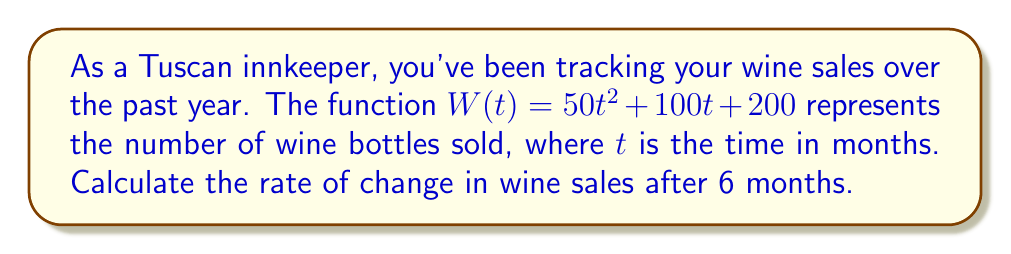Could you help me with this problem? To find the rate of change in wine sales after 6 months, we need to calculate the derivative of the given function $W(t)$ and then evaluate it at $t = 6$.

Step 1: Find the derivative of $W(t)$
$$W(t) = 50t^2 + 100t + 200$$
$$W'(t) = 100t + 100$$

The derivative represents the instantaneous rate of change of wine sales with respect to time.

Step 2: Evaluate the derivative at $t = 6$
$$W'(6) = 100(6) + 100$$
$$W'(6) = 600 + 100 = 700$$

This means that after 6 months, the rate of change in wine sales is 700 bottles per month.
Answer: 700 bottles/month 